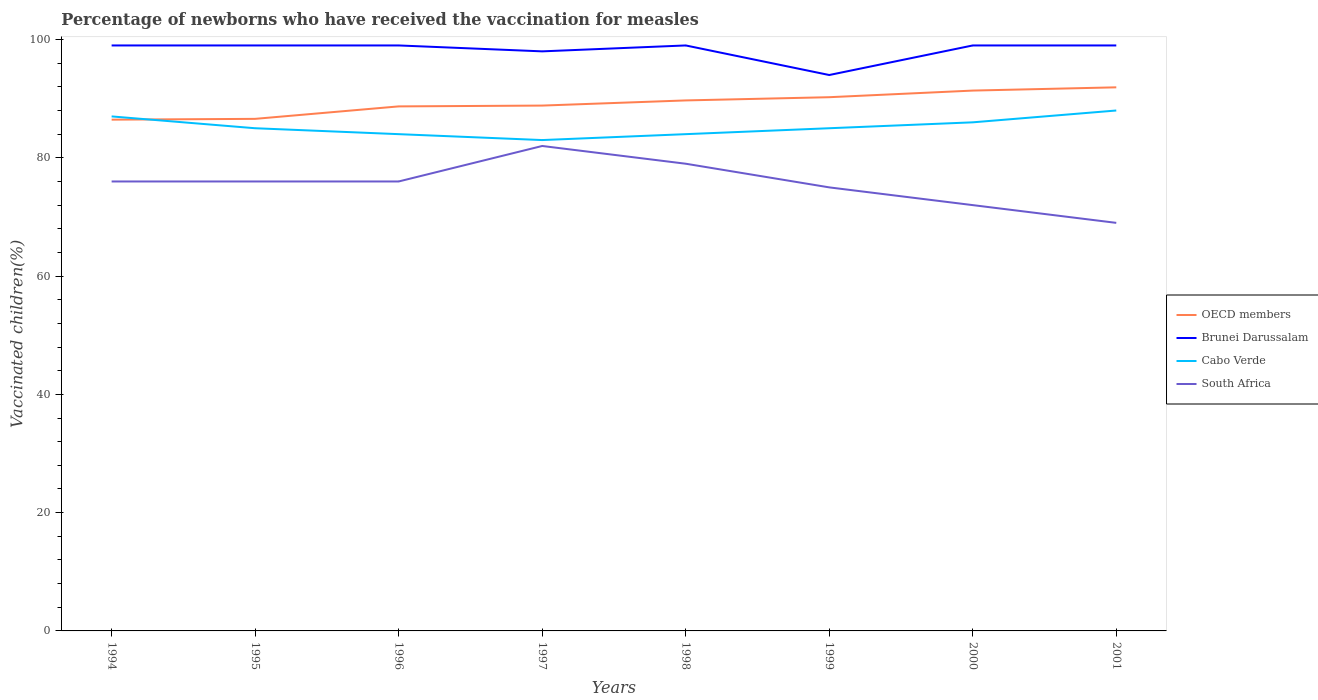Is the number of lines equal to the number of legend labels?
Your response must be concise. Yes. In which year was the percentage of vaccinated children in Brunei Darussalam maximum?
Your answer should be compact. 1999. What is the difference between the highest and the second highest percentage of vaccinated children in Brunei Darussalam?
Offer a very short reply. 5. Is the percentage of vaccinated children in OECD members strictly greater than the percentage of vaccinated children in Brunei Darussalam over the years?
Give a very brief answer. Yes. How many years are there in the graph?
Ensure brevity in your answer.  8. What is the difference between two consecutive major ticks on the Y-axis?
Offer a terse response. 20. Are the values on the major ticks of Y-axis written in scientific E-notation?
Keep it short and to the point. No. Does the graph contain any zero values?
Ensure brevity in your answer.  No. Does the graph contain grids?
Provide a succinct answer. No. What is the title of the graph?
Your answer should be compact. Percentage of newborns who have received the vaccination for measles. Does "Northern Mariana Islands" appear as one of the legend labels in the graph?
Provide a succinct answer. No. What is the label or title of the X-axis?
Offer a very short reply. Years. What is the label or title of the Y-axis?
Ensure brevity in your answer.  Vaccinated children(%). What is the Vaccinated children(%) of OECD members in 1994?
Provide a succinct answer. 86.45. What is the Vaccinated children(%) in Cabo Verde in 1994?
Your answer should be very brief. 87. What is the Vaccinated children(%) of OECD members in 1995?
Offer a very short reply. 86.59. What is the Vaccinated children(%) of South Africa in 1995?
Offer a very short reply. 76. What is the Vaccinated children(%) of OECD members in 1996?
Provide a short and direct response. 88.69. What is the Vaccinated children(%) of Cabo Verde in 1996?
Ensure brevity in your answer.  84. What is the Vaccinated children(%) in OECD members in 1997?
Make the answer very short. 88.83. What is the Vaccinated children(%) in Brunei Darussalam in 1997?
Ensure brevity in your answer.  98. What is the Vaccinated children(%) in Cabo Verde in 1997?
Give a very brief answer. 83. What is the Vaccinated children(%) of OECD members in 1998?
Your answer should be compact. 89.7. What is the Vaccinated children(%) of Brunei Darussalam in 1998?
Your answer should be very brief. 99. What is the Vaccinated children(%) in Cabo Verde in 1998?
Offer a very short reply. 84. What is the Vaccinated children(%) in South Africa in 1998?
Your response must be concise. 79. What is the Vaccinated children(%) of OECD members in 1999?
Your answer should be very brief. 90.25. What is the Vaccinated children(%) of Brunei Darussalam in 1999?
Provide a short and direct response. 94. What is the Vaccinated children(%) of Cabo Verde in 1999?
Offer a very short reply. 85. What is the Vaccinated children(%) in OECD members in 2000?
Keep it short and to the point. 91.37. What is the Vaccinated children(%) of Brunei Darussalam in 2000?
Give a very brief answer. 99. What is the Vaccinated children(%) of OECD members in 2001?
Provide a short and direct response. 91.92. What is the Vaccinated children(%) in Brunei Darussalam in 2001?
Offer a very short reply. 99. What is the Vaccinated children(%) in Cabo Verde in 2001?
Provide a short and direct response. 88. What is the Vaccinated children(%) in South Africa in 2001?
Your answer should be very brief. 69. Across all years, what is the maximum Vaccinated children(%) in OECD members?
Your response must be concise. 91.92. Across all years, what is the maximum Vaccinated children(%) of Cabo Verde?
Your answer should be very brief. 88. Across all years, what is the minimum Vaccinated children(%) of OECD members?
Ensure brevity in your answer.  86.45. Across all years, what is the minimum Vaccinated children(%) of Brunei Darussalam?
Keep it short and to the point. 94. Across all years, what is the minimum Vaccinated children(%) in South Africa?
Provide a short and direct response. 69. What is the total Vaccinated children(%) in OECD members in the graph?
Ensure brevity in your answer.  713.81. What is the total Vaccinated children(%) of Brunei Darussalam in the graph?
Your answer should be compact. 786. What is the total Vaccinated children(%) in Cabo Verde in the graph?
Ensure brevity in your answer.  682. What is the total Vaccinated children(%) in South Africa in the graph?
Give a very brief answer. 605. What is the difference between the Vaccinated children(%) of OECD members in 1994 and that in 1995?
Ensure brevity in your answer.  -0.14. What is the difference between the Vaccinated children(%) in Brunei Darussalam in 1994 and that in 1995?
Provide a short and direct response. 0. What is the difference between the Vaccinated children(%) of Cabo Verde in 1994 and that in 1995?
Keep it short and to the point. 2. What is the difference between the Vaccinated children(%) of South Africa in 1994 and that in 1995?
Your response must be concise. 0. What is the difference between the Vaccinated children(%) in OECD members in 1994 and that in 1996?
Keep it short and to the point. -2.24. What is the difference between the Vaccinated children(%) of Cabo Verde in 1994 and that in 1996?
Offer a very short reply. 3. What is the difference between the Vaccinated children(%) of OECD members in 1994 and that in 1997?
Offer a very short reply. -2.38. What is the difference between the Vaccinated children(%) of Brunei Darussalam in 1994 and that in 1997?
Provide a short and direct response. 1. What is the difference between the Vaccinated children(%) of South Africa in 1994 and that in 1997?
Provide a succinct answer. -6. What is the difference between the Vaccinated children(%) in OECD members in 1994 and that in 1998?
Provide a succinct answer. -3.25. What is the difference between the Vaccinated children(%) of Cabo Verde in 1994 and that in 1998?
Provide a short and direct response. 3. What is the difference between the Vaccinated children(%) of South Africa in 1994 and that in 1998?
Ensure brevity in your answer.  -3. What is the difference between the Vaccinated children(%) of OECD members in 1994 and that in 1999?
Ensure brevity in your answer.  -3.8. What is the difference between the Vaccinated children(%) in Cabo Verde in 1994 and that in 1999?
Give a very brief answer. 2. What is the difference between the Vaccinated children(%) in South Africa in 1994 and that in 1999?
Your response must be concise. 1. What is the difference between the Vaccinated children(%) in OECD members in 1994 and that in 2000?
Your answer should be compact. -4.92. What is the difference between the Vaccinated children(%) of Cabo Verde in 1994 and that in 2000?
Ensure brevity in your answer.  1. What is the difference between the Vaccinated children(%) of South Africa in 1994 and that in 2000?
Your response must be concise. 4. What is the difference between the Vaccinated children(%) of OECD members in 1994 and that in 2001?
Your response must be concise. -5.47. What is the difference between the Vaccinated children(%) of OECD members in 1995 and that in 1996?
Provide a short and direct response. -2.11. What is the difference between the Vaccinated children(%) of Cabo Verde in 1995 and that in 1996?
Offer a very short reply. 1. What is the difference between the Vaccinated children(%) of OECD members in 1995 and that in 1997?
Give a very brief answer. -2.25. What is the difference between the Vaccinated children(%) of South Africa in 1995 and that in 1997?
Your response must be concise. -6. What is the difference between the Vaccinated children(%) of OECD members in 1995 and that in 1998?
Provide a short and direct response. -3.12. What is the difference between the Vaccinated children(%) in Brunei Darussalam in 1995 and that in 1998?
Offer a very short reply. 0. What is the difference between the Vaccinated children(%) in South Africa in 1995 and that in 1998?
Ensure brevity in your answer.  -3. What is the difference between the Vaccinated children(%) in OECD members in 1995 and that in 1999?
Keep it short and to the point. -3.66. What is the difference between the Vaccinated children(%) in Brunei Darussalam in 1995 and that in 1999?
Make the answer very short. 5. What is the difference between the Vaccinated children(%) in Cabo Verde in 1995 and that in 1999?
Offer a very short reply. 0. What is the difference between the Vaccinated children(%) in OECD members in 1995 and that in 2000?
Provide a succinct answer. -4.78. What is the difference between the Vaccinated children(%) of Brunei Darussalam in 1995 and that in 2000?
Offer a very short reply. 0. What is the difference between the Vaccinated children(%) of South Africa in 1995 and that in 2000?
Keep it short and to the point. 4. What is the difference between the Vaccinated children(%) in OECD members in 1995 and that in 2001?
Offer a terse response. -5.33. What is the difference between the Vaccinated children(%) in Brunei Darussalam in 1995 and that in 2001?
Offer a very short reply. 0. What is the difference between the Vaccinated children(%) in Cabo Verde in 1995 and that in 2001?
Keep it short and to the point. -3. What is the difference between the Vaccinated children(%) in OECD members in 1996 and that in 1997?
Provide a succinct answer. -0.14. What is the difference between the Vaccinated children(%) of Brunei Darussalam in 1996 and that in 1997?
Your answer should be compact. 1. What is the difference between the Vaccinated children(%) of South Africa in 1996 and that in 1997?
Ensure brevity in your answer.  -6. What is the difference between the Vaccinated children(%) in OECD members in 1996 and that in 1998?
Provide a short and direct response. -1.01. What is the difference between the Vaccinated children(%) in Brunei Darussalam in 1996 and that in 1998?
Your response must be concise. 0. What is the difference between the Vaccinated children(%) in OECD members in 1996 and that in 1999?
Ensure brevity in your answer.  -1.55. What is the difference between the Vaccinated children(%) in Brunei Darussalam in 1996 and that in 1999?
Provide a short and direct response. 5. What is the difference between the Vaccinated children(%) in Cabo Verde in 1996 and that in 1999?
Provide a succinct answer. -1. What is the difference between the Vaccinated children(%) in South Africa in 1996 and that in 1999?
Your answer should be compact. 1. What is the difference between the Vaccinated children(%) of OECD members in 1996 and that in 2000?
Keep it short and to the point. -2.67. What is the difference between the Vaccinated children(%) of Cabo Verde in 1996 and that in 2000?
Ensure brevity in your answer.  -2. What is the difference between the Vaccinated children(%) in South Africa in 1996 and that in 2000?
Make the answer very short. 4. What is the difference between the Vaccinated children(%) of OECD members in 1996 and that in 2001?
Provide a succinct answer. -3.22. What is the difference between the Vaccinated children(%) of Cabo Verde in 1996 and that in 2001?
Your answer should be very brief. -4. What is the difference between the Vaccinated children(%) in South Africa in 1996 and that in 2001?
Offer a very short reply. 7. What is the difference between the Vaccinated children(%) in OECD members in 1997 and that in 1998?
Make the answer very short. -0.87. What is the difference between the Vaccinated children(%) of Brunei Darussalam in 1997 and that in 1998?
Your response must be concise. -1. What is the difference between the Vaccinated children(%) of South Africa in 1997 and that in 1998?
Give a very brief answer. 3. What is the difference between the Vaccinated children(%) in OECD members in 1997 and that in 1999?
Keep it short and to the point. -1.41. What is the difference between the Vaccinated children(%) of Cabo Verde in 1997 and that in 1999?
Offer a very short reply. -2. What is the difference between the Vaccinated children(%) of OECD members in 1997 and that in 2000?
Your answer should be very brief. -2.54. What is the difference between the Vaccinated children(%) in South Africa in 1997 and that in 2000?
Give a very brief answer. 10. What is the difference between the Vaccinated children(%) of OECD members in 1997 and that in 2001?
Keep it short and to the point. -3.08. What is the difference between the Vaccinated children(%) of South Africa in 1997 and that in 2001?
Provide a succinct answer. 13. What is the difference between the Vaccinated children(%) of OECD members in 1998 and that in 1999?
Your answer should be very brief. -0.54. What is the difference between the Vaccinated children(%) of Cabo Verde in 1998 and that in 1999?
Keep it short and to the point. -1. What is the difference between the Vaccinated children(%) of OECD members in 1998 and that in 2000?
Provide a short and direct response. -1.67. What is the difference between the Vaccinated children(%) of Brunei Darussalam in 1998 and that in 2000?
Your response must be concise. 0. What is the difference between the Vaccinated children(%) of Cabo Verde in 1998 and that in 2000?
Ensure brevity in your answer.  -2. What is the difference between the Vaccinated children(%) of South Africa in 1998 and that in 2000?
Keep it short and to the point. 7. What is the difference between the Vaccinated children(%) in OECD members in 1998 and that in 2001?
Provide a short and direct response. -2.21. What is the difference between the Vaccinated children(%) of OECD members in 1999 and that in 2000?
Ensure brevity in your answer.  -1.12. What is the difference between the Vaccinated children(%) of South Africa in 1999 and that in 2000?
Your answer should be very brief. 3. What is the difference between the Vaccinated children(%) of OECD members in 1999 and that in 2001?
Offer a very short reply. -1.67. What is the difference between the Vaccinated children(%) in Cabo Verde in 1999 and that in 2001?
Offer a very short reply. -3. What is the difference between the Vaccinated children(%) of South Africa in 1999 and that in 2001?
Offer a very short reply. 6. What is the difference between the Vaccinated children(%) in OECD members in 2000 and that in 2001?
Keep it short and to the point. -0.55. What is the difference between the Vaccinated children(%) in Brunei Darussalam in 2000 and that in 2001?
Your answer should be compact. 0. What is the difference between the Vaccinated children(%) of Cabo Verde in 2000 and that in 2001?
Your response must be concise. -2. What is the difference between the Vaccinated children(%) in OECD members in 1994 and the Vaccinated children(%) in Brunei Darussalam in 1995?
Your answer should be very brief. -12.55. What is the difference between the Vaccinated children(%) of OECD members in 1994 and the Vaccinated children(%) of Cabo Verde in 1995?
Your response must be concise. 1.45. What is the difference between the Vaccinated children(%) of OECD members in 1994 and the Vaccinated children(%) of South Africa in 1995?
Provide a short and direct response. 10.45. What is the difference between the Vaccinated children(%) in Brunei Darussalam in 1994 and the Vaccinated children(%) in South Africa in 1995?
Provide a short and direct response. 23. What is the difference between the Vaccinated children(%) of Cabo Verde in 1994 and the Vaccinated children(%) of South Africa in 1995?
Your response must be concise. 11. What is the difference between the Vaccinated children(%) of OECD members in 1994 and the Vaccinated children(%) of Brunei Darussalam in 1996?
Provide a short and direct response. -12.55. What is the difference between the Vaccinated children(%) in OECD members in 1994 and the Vaccinated children(%) in Cabo Verde in 1996?
Make the answer very short. 2.45. What is the difference between the Vaccinated children(%) in OECD members in 1994 and the Vaccinated children(%) in South Africa in 1996?
Make the answer very short. 10.45. What is the difference between the Vaccinated children(%) of Brunei Darussalam in 1994 and the Vaccinated children(%) of Cabo Verde in 1996?
Ensure brevity in your answer.  15. What is the difference between the Vaccinated children(%) of Brunei Darussalam in 1994 and the Vaccinated children(%) of South Africa in 1996?
Offer a terse response. 23. What is the difference between the Vaccinated children(%) in Cabo Verde in 1994 and the Vaccinated children(%) in South Africa in 1996?
Give a very brief answer. 11. What is the difference between the Vaccinated children(%) of OECD members in 1994 and the Vaccinated children(%) of Brunei Darussalam in 1997?
Provide a short and direct response. -11.55. What is the difference between the Vaccinated children(%) of OECD members in 1994 and the Vaccinated children(%) of Cabo Verde in 1997?
Your answer should be compact. 3.45. What is the difference between the Vaccinated children(%) of OECD members in 1994 and the Vaccinated children(%) of South Africa in 1997?
Ensure brevity in your answer.  4.45. What is the difference between the Vaccinated children(%) in Brunei Darussalam in 1994 and the Vaccinated children(%) in Cabo Verde in 1997?
Ensure brevity in your answer.  16. What is the difference between the Vaccinated children(%) of OECD members in 1994 and the Vaccinated children(%) of Brunei Darussalam in 1998?
Your answer should be very brief. -12.55. What is the difference between the Vaccinated children(%) of OECD members in 1994 and the Vaccinated children(%) of Cabo Verde in 1998?
Give a very brief answer. 2.45. What is the difference between the Vaccinated children(%) in OECD members in 1994 and the Vaccinated children(%) in South Africa in 1998?
Give a very brief answer. 7.45. What is the difference between the Vaccinated children(%) of Brunei Darussalam in 1994 and the Vaccinated children(%) of Cabo Verde in 1998?
Provide a succinct answer. 15. What is the difference between the Vaccinated children(%) in Brunei Darussalam in 1994 and the Vaccinated children(%) in South Africa in 1998?
Make the answer very short. 20. What is the difference between the Vaccinated children(%) in OECD members in 1994 and the Vaccinated children(%) in Brunei Darussalam in 1999?
Offer a terse response. -7.55. What is the difference between the Vaccinated children(%) of OECD members in 1994 and the Vaccinated children(%) of Cabo Verde in 1999?
Offer a terse response. 1.45. What is the difference between the Vaccinated children(%) in OECD members in 1994 and the Vaccinated children(%) in South Africa in 1999?
Make the answer very short. 11.45. What is the difference between the Vaccinated children(%) of Cabo Verde in 1994 and the Vaccinated children(%) of South Africa in 1999?
Make the answer very short. 12. What is the difference between the Vaccinated children(%) of OECD members in 1994 and the Vaccinated children(%) of Brunei Darussalam in 2000?
Provide a succinct answer. -12.55. What is the difference between the Vaccinated children(%) of OECD members in 1994 and the Vaccinated children(%) of Cabo Verde in 2000?
Your response must be concise. 0.45. What is the difference between the Vaccinated children(%) in OECD members in 1994 and the Vaccinated children(%) in South Africa in 2000?
Provide a succinct answer. 14.45. What is the difference between the Vaccinated children(%) in Brunei Darussalam in 1994 and the Vaccinated children(%) in South Africa in 2000?
Offer a terse response. 27. What is the difference between the Vaccinated children(%) in OECD members in 1994 and the Vaccinated children(%) in Brunei Darussalam in 2001?
Your response must be concise. -12.55. What is the difference between the Vaccinated children(%) in OECD members in 1994 and the Vaccinated children(%) in Cabo Verde in 2001?
Your answer should be compact. -1.55. What is the difference between the Vaccinated children(%) in OECD members in 1994 and the Vaccinated children(%) in South Africa in 2001?
Provide a short and direct response. 17.45. What is the difference between the Vaccinated children(%) of Brunei Darussalam in 1994 and the Vaccinated children(%) of Cabo Verde in 2001?
Your response must be concise. 11. What is the difference between the Vaccinated children(%) in Brunei Darussalam in 1994 and the Vaccinated children(%) in South Africa in 2001?
Your answer should be compact. 30. What is the difference between the Vaccinated children(%) of Cabo Verde in 1994 and the Vaccinated children(%) of South Africa in 2001?
Offer a terse response. 18. What is the difference between the Vaccinated children(%) of OECD members in 1995 and the Vaccinated children(%) of Brunei Darussalam in 1996?
Give a very brief answer. -12.41. What is the difference between the Vaccinated children(%) of OECD members in 1995 and the Vaccinated children(%) of Cabo Verde in 1996?
Your response must be concise. 2.59. What is the difference between the Vaccinated children(%) of OECD members in 1995 and the Vaccinated children(%) of South Africa in 1996?
Offer a very short reply. 10.59. What is the difference between the Vaccinated children(%) of Brunei Darussalam in 1995 and the Vaccinated children(%) of Cabo Verde in 1996?
Keep it short and to the point. 15. What is the difference between the Vaccinated children(%) of Brunei Darussalam in 1995 and the Vaccinated children(%) of South Africa in 1996?
Your answer should be compact. 23. What is the difference between the Vaccinated children(%) of Cabo Verde in 1995 and the Vaccinated children(%) of South Africa in 1996?
Offer a terse response. 9. What is the difference between the Vaccinated children(%) in OECD members in 1995 and the Vaccinated children(%) in Brunei Darussalam in 1997?
Make the answer very short. -11.41. What is the difference between the Vaccinated children(%) in OECD members in 1995 and the Vaccinated children(%) in Cabo Verde in 1997?
Ensure brevity in your answer.  3.59. What is the difference between the Vaccinated children(%) of OECD members in 1995 and the Vaccinated children(%) of South Africa in 1997?
Provide a succinct answer. 4.59. What is the difference between the Vaccinated children(%) in OECD members in 1995 and the Vaccinated children(%) in Brunei Darussalam in 1998?
Ensure brevity in your answer.  -12.41. What is the difference between the Vaccinated children(%) of OECD members in 1995 and the Vaccinated children(%) of Cabo Verde in 1998?
Your answer should be very brief. 2.59. What is the difference between the Vaccinated children(%) of OECD members in 1995 and the Vaccinated children(%) of South Africa in 1998?
Keep it short and to the point. 7.59. What is the difference between the Vaccinated children(%) in Brunei Darussalam in 1995 and the Vaccinated children(%) in Cabo Verde in 1998?
Provide a succinct answer. 15. What is the difference between the Vaccinated children(%) in Brunei Darussalam in 1995 and the Vaccinated children(%) in South Africa in 1998?
Offer a very short reply. 20. What is the difference between the Vaccinated children(%) in OECD members in 1995 and the Vaccinated children(%) in Brunei Darussalam in 1999?
Your answer should be compact. -7.41. What is the difference between the Vaccinated children(%) of OECD members in 1995 and the Vaccinated children(%) of Cabo Verde in 1999?
Offer a terse response. 1.59. What is the difference between the Vaccinated children(%) in OECD members in 1995 and the Vaccinated children(%) in South Africa in 1999?
Provide a short and direct response. 11.59. What is the difference between the Vaccinated children(%) of Brunei Darussalam in 1995 and the Vaccinated children(%) of South Africa in 1999?
Offer a very short reply. 24. What is the difference between the Vaccinated children(%) of OECD members in 1995 and the Vaccinated children(%) of Brunei Darussalam in 2000?
Your response must be concise. -12.41. What is the difference between the Vaccinated children(%) of OECD members in 1995 and the Vaccinated children(%) of Cabo Verde in 2000?
Ensure brevity in your answer.  0.59. What is the difference between the Vaccinated children(%) in OECD members in 1995 and the Vaccinated children(%) in South Africa in 2000?
Give a very brief answer. 14.59. What is the difference between the Vaccinated children(%) in Brunei Darussalam in 1995 and the Vaccinated children(%) in Cabo Verde in 2000?
Provide a succinct answer. 13. What is the difference between the Vaccinated children(%) of Brunei Darussalam in 1995 and the Vaccinated children(%) of South Africa in 2000?
Your response must be concise. 27. What is the difference between the Vaccinated children(%) of OECD members in 1995 and the Vaccinated children(%) of Brunei Darussalam in 2001?
Offer a terse response. -12.41. What is the difference between the Vaccinated children(%) of OECD members in 1995 and the Vaccinated children(%) of Cabo Verde in 2001?
Provide a succinct answer. -1.41. What is the difference between the Vaccinated children(%) of OECD members in 1995 and the Vaccinated children(%) of South Africa in 2001?
Make the answer very short. 17.59. What is the difference between the Vaccinated children(%) of Brunei Darussalam in 1995 and the Vaccinated children(%) of Cabo Verde in 2001?
Provide a short and direct response. 11. What is the difference between the Vaccinated children(%) of Cabo Verde in 1995 and the Vaccinated children(%) of South Africa in 2001?
Your response must be concise. 16. What is the difference between the Vaccinated children(%) in OECD members in 1996 and the Vaccinated children(%) in Brunei Darussalam in 1997?
Provide a succinct answer. -9.31. What is the difference between the Vaccinated children(%) in OECD members in 1996 and the Vaccinated children(%) in Cabo Verde in 1997?
Your answer should be compact. 5.69. What is the difference between the Vaccinated children(%) of OECD members in 1996 and the Vaccinated children(%) of South Africa in 1997?
Offer a terse response. 6.69. What is the difference between the Vaccinated children(%) of Brunei Darussalam in 1996 and the Vaccinated children(%) of Cabo Verde in 1997?
Give a very brief answer. 16. What is the difference between the Vaccinated children(%) in OECD members in 1996 and the Vaccinated children(%) in Brunei Darussalam in 1998?
Offer a terse response. -10.31. What is the difference between the Vaccinated children(%) in OECD members in 1996 and the Vaccinated children(%) in Cabo Verde in 1998?
Ensure brevity in your answer.  4.69. What is the difference between the Vaccinated children(%) of OECD members in 1996 and the Vaccinated children(%) of South Africa in 1998?
Ensure brevity in your answer.  9.69. What is the difference between the Vaccinated children(%) of Brunei Darussalam in 1996 and the Vaccinated children(%) of South Africa in 1998?
Offer a very short reply. 20. What is the difference between the Vaccinated children(%) in Cabo Verde in 1996 and the Vaccinated children(%) in South Africa in 1998?
Offer a terse response. 5. What is the difference between the Vaccinated children(%) of OECD members in 1996 and the Vaccinated children(%) of Brunei Darussalam in 1999?
Keep it short and to the point. -5.31. What is the difference between the Vaccinated children(%) of OECD members in 1996 and the Vaccinated children(%) of Cabo Verde in 1999?
Ensure brevity in your answer.  3.69. What is the difference between the Vaccinated children(%) of OECD members in 1996 and the Vaccinated children(%) of South Africa in 1999?
Provide a succinct answer. 13.69. What is the difference between the Vaccinated children(%) in Cabo Verde in 1996 and the Vaccinated children(%) in South Africa in 1999?
Your response must be concise. 9. What is the difference between the Vaccinated children(%) in OECD members in 1996 and the Vaccinated children(%) in Brunei Darussalam in 2000?
Offer a terse response. -10.31. What is the difference between the Vaccinated children(%) in OECD members in 1996 and the Vaccinated children(%) in Cabo Verde in 2000?
Make the answer very short. 2.69. What is the difference between the Vaccinated children(%) of OECD members in 1996 and the Vaccinated children(%) of South Africa in 2000?
Provide a succinct answer. 16.69. What is the difference between the Vaccinated children(%) in Brunei Darussalam in 1996 and the Vaccinated children(%) in Cabo Verde in 2000?
Ensure brevity in your answer.  13. What is the difference between the Vaccinated children(%) in OECD members in 1996 and the Vaccinated children(%) in Brunei Darussalam in 2001?
Your answer should be compact. -10.31. What is the difference between the Vaccinated children(%) of OECD members in 1996 and the Vaccinated children(%) of Cabo Verde in 2001?
Ensure brevity in your answer.  0.69. What is the difference between the Vaccinated children(%) in OECD members in 1996 and the Vaccinated children(%) in South Africa in 2001?
Your answer should be very brief. 19.69. What is the difference between the Vaccinated children(%) in Brunei Darussalam in 1996 and the Vaccinated children(%) in Cabo Verde in 2001?
Ensure brevity in your answer.  11. What is the difference between the Vaccinated children(%) in OECD members in 1997 and the Vaccinated children(%) in Brunei Darussalam in 1998?
Give a very brief answer. -10.17. What is the difference between the Vaccinated children(%) in OECD members in 1997 and the Vaccinated children(%) in Cabo Verde in 1998?
Your answer should be compact. 4.83. What is the difference between the Vaccinated children(%) of OECD members in 1997 and the Vaccinated children(%) of South Africa in 1998?
Provide a short and direct response. 9.83. What is the difference between the Vaccinated children(%) in Cabo Verde in 1997 and the Vaccinated children(%) in South Africa in 1998?
Your answer should be very brief. 4. What is the difference between the Vaccinated children(%) in OECD members in 1997 and the Vaccinated children(%) in Brunei Darussalam in 1999?
Provide a succinct answer. -5.17. What is the difference between the Vaccinated children(%) of OECD members in 1997 and the Vaccinated children(%) of Cabo Verde in 1999?
Your response must be concise. 3.83. What is the difference between the Vaccinated children(%) of OECD members in 1997 and the Vaccinated children(%) of South Africa in 1999?
Your answer should be compact. 13.83. What is the difference between the Vaccinated children(%) of Brunei Darussalam in 1997 and the Vaccinated children(%) of South Africa in 1999?
Your response must be concise. 23. What is the difference between the Vaccinated children(%) in OECD members in 1997 and the Vaccinated children(%) in Brunei Darussalam in 2000?
Your response must be concise. -10.17. What is the difference between the Vaccinated children(%) of OECD members in 1997 and the Vaccinated children(%) of Cabo Verde in 2000?
Offer a very short reply. 2.83. What is the difference between the Vaccinated children(%) in OECD members in 1997 and the Vaccinated children(%) in South Africa in 2000?
Give a very brief answer. 16.83. What is the difference between the Vaccinated children(%) of Brunei Darussalam in 1997 and the Vaccinated children(%) of South Africa in 2000?
Offer a very short reply. 26. What is the difference between the Vaccinated children(%) in OECD members in 1997 and the Vaccinated children(%) in Brunei Darussalam in 2001?
Offer a terse response. -10.17. What is the difference between the Vaccinated children(%) of OECD members in 1997 and the Vaccinated children(%) of Cabo Verde in 2001?
Offer a terse response. 0.83. What is the difference between the Vaccinated children(%) of OECD members in 1997 and the Vaccinated children(%) of South Africa in 2001?
Your answer should be compact. 19.83. What is the difference between the Vaccinated children(%) of Brunei Darussalam in 1997 and the Vaccinated children(%) of South Africa in 2001?
Provide a short and direct response. 29. What is the difference between the Vaccinated children(%) in OECD members in 1998 and the Vaccinated children(%) in Brunei Darussalam in 1999?
Your answer should be compact. -4.3. What is the difference between the Vaccinated children(%) of OECD members in 1998 and the Vaccinated children(%) of Cabo Verde in 1999?
Offer a terse response. 4.7. What is the difference between the Vaccinated children(%) in OECD members in 1998 and the Vaccinated children(%) in South Africa in 1999?
Your answer should be very brief. 14.7. What is the difference between the Vaccinated children(%) of Brunei Darussalam in 1998 and the Vaccinated children(%) of Cabo Verde in 1999?
Ensure brevity in your answer.  14. What is the difference between the Vaccinated children(%) in Brunei Darussalam in 1998 and the Vaccinated children(%) in South Africa in 1999?
Provide a short and direct response. 24. What is the difference between the Vaccinated children(%) in OECD members in 1998 and the Vaccinated children(%) in Brunei Darussalam in 2000?
Your answer should be compact. -9.3. What is the difference between the Vaccinated children(%) of OECD members in 1998 and the Vaccinated children(%) of Cabo Verde in 2000?
Offer a terse response. 3.7. What is the difference between the Vaccinated children(%) in OECD members in 1998 and the Vaccinated children(%) in South Africa in 2000?
Make the answer very short. 17.7. What is the difference between the Vaccinated children(%) in Brunei Darussalam in 1998 and the Vaccinated children(%) in Cabo Verde in 2000?
Your answer should be compact. 13. What is the difference between the Vaccinated children(%) in Cabo Verde in 1998 and the Vaccinated children(%) in South Africa in 2000?
Make the answer very short. 12. What is the difference between the Vaccinated children(%) in OECD members in 1998 and the Vaccinated children(%) in Brunei Darussalam in 2001?
Your answer should be compact. -9.3. What is the difference between the Vaccinated children(%) in OECD members in 1998 and the Vaccinated children(%) in Cabo Verde in 2001?
Make the answer very short. 1.7. What is the difference between the Vaccinated children(%) in OECD members in 1998 and the Vaccinated children(%) in South Africa in 2001?
Your answer should be compact. 20.7. What is the difference between the Vaccinated children(%) in Brunei Darussalam in 1998 and the Vaccinated children(%) in South Africa in 2001?
Ensure brevity in your answer.  30. What is the difference between the Vaccinated children(%) in Cabo Verde in 1998 and the Vaccinated children(%) in South Africa in 2001?
Provide a short and direct response. 15. What is the difference between the Vaccinated children(%) in OECD members in 1999 and the Vaccinated children(%) in Brunei Darussalam in 2000?
Provide a succinct answer. -8.75. What is the difference between the Vaccinated children(%) of OECD members in 1999 and the Vaccinated children(%) of Cabo Verde in 2000?
Give a very brief answer. 4.25. What is the difference between the Vaccinated children(%) in OECD members in 1999 and the Vaccinated children(%) in South Africa in 2000?
Provide a succinct answer. 18.25. What is the difference between the Vaccinated children(%) of Brunei Darussalam in 1999 and the Vaccinated children(%) of Cabo Verde in 2000?
Provide a succinct answer. 8. What is the difference between the Vaccinated children(%) of Brunei Darussalam in 1999 and the Vaccinated children(%) of South Africa in 2000?
Offer a very short reply. 22. What is the difference between the Vaccinated children(%) in Cabo Verde in 1999 and the Vaccinated children(%) in South Africa in 2000?
Your response must be concise. 13. What is the difference between the Vaccinated children(%) of OECD members in 1999 and the Vaccinated children(%) of Brunei Darussalam in 2001?
Your response must be concise. -8.75. What is the difference between the Vaccinated children(%) in OECD members in 1999 and the Vaccinated children(%) in Cabo Verde in 2001?
Keep it short and to the point. 2.25. What is the difference between the Vaccinated children(%) of OECD members in 1999 and the Vaccinated children(%) of South Africa in 2001?
Keep it short and to the point. 21.25. What is the difference between the Vaccinated children(%) in OECD members in 2000 and the Vaccinated children(%) in Brunei Darussalam in 2001?
Your answer should be very brief. -7.63. What is the difference between the Vaccinated children(%) of OECD members in 2000 and the Vaccinated children(%) of Cabo Verde in 2001?
Your response must be concise. 3.37. What is the difference between the Vaccinated children(%) in OECD members in 2000 and the Vaccinated children(%) in South Africa in 2001?
Your answer should be very brief. 22.37. What is the difference between the Vaccinated children(%) of Brunei Darussalam in 2000 and the Vaccinated children(%) of South Africa in 2001?
Offer a terse response. 30. What is the average Vaccinated children(%) of OECD members per year?
Provide a short and direct response. 89.23. What is the average Vaccinated children(%) of Brunei Darussalam per year?
Give a very brief answer. 98.25. What is the average Vaccinated children(%) of Cabo Verde per year?
Make the answer very short. 85.25. What is the average Vaccinated children(%) of South Africa per year?
Provide a short and direct response. 75.62. In the year 1994, what is the difference between the Vaccinated children(%) of OECD members and Vaccinated children(%) of Brunei Darussalam?
Your answer should be very brief. -12.55. In the year 1994, what is the difference between the Vaccinated children(%) in OECD members and Vaccinated children(%) in Cabo Verde?
Give a very brief answer. -0.55. In the year 1994, what is the difference between the Vaccinated children(%) of OECD members and Vaccinated children(%) of South Africa?
Offer a very short reply. 10.45. In the year 1994, what is the difference between the Vaccinated children(%) in Cabo Verde and Vaccinated children(%) in South Africa?
Give a very brief answer. 11. In the year 1995, what is the difference between the Vaccinated children(%) of OECD members and Vaccinated children(%) of Brunei Darussalam?
Make the answer very short. -12.41. In the year 1995, what is the difference between the Vaccinated children(%) in OECD members and Vaccinated children(%) in Cabo Verde?
Provide a succinct answer. 1.59. In the year 1995, what is the difference between the Vaccinated children(%) of OECD members and Vaccinated children(%) of South Africa?
Ensure brevity in your answer.  10.59. In the year 1996, what is the difference between the Vaccinated children(%) in OECD members and Vaccinated children(%) in Brunei Darussalam?
Your response must be concise. -10.31. In the year 1996, what is the difference between the Vaccinated children(%) of OECD members and Vaccinated children(%) of Cabo Verde?
Give a very brief answer. 4.69. In the year 1996, what is the difference between the Vaccinated children(%) in OECD members and Vaccinated children(%) in South Africa?
Your response must be concise. 12.69. In the year 1997, what is the difference between the Vaccinated children(%) in OECD members and Vaccinated children(%) in Brunei Darussalam?
Offer a very short reply. -9.17. In the year 1997, what is the difference between the Vaccinated children(%) in OECD members and Vaccinated children(%) in Cabo Verde?
Your response must be concise. 5.83. In the year 1997, what is the difference between the Vaccinated children(%) in OECD members and Vaccinated children(%) in South Africa?
Offer a terse response. 6.83. In the year 1997, what is the difference between the Vaccinated children(%) in Brunei Darussalam and Vaccinated children(%) in Cabo Verde?
Offer a terse response. 15. In the year 1998, what is the difference between the Vaccinated children(%) of OECD members and Vaccinated children(%) of Brunei Darussalam?
Offer a terse response. -9.3. In the year 1998, what is the difference between the Vaccinated children(%) of OECD members and Vaccinated children(%) of Cabo Verde?
Your answer should be very brief. 5.7. In the year 1998, what is the difference between the Vaccinated children(%) of OECD members and Vaccinated children(%) of South Africa?
Ensure brevity in your answer.  10.7. In the year 1998, what is the difference between the Vaccinated children(%) in Cabo Verde and Vaccinated children(%) in South Africa?
Offer a very short reply. 5. In the year 1999, what is the difference between the Vaccinated children(%) in OECD members and Vaccinated children(%) in Brunei Darussalam?
Ensure brevity in your answer.  -3.75. In the year 1999, what is the difference between the Vaccinated children(%) in OECD members and Vaccinated children(%) in Cabo Verde?
Keep it short and to the point. 5.25. In the year 1999, what is the difference between the Vaccinated children(%) of OECD members and Vaccinated children(%) of South Africa?
Keep it short and to the point. 15.25. In the year 1999, what is the difference between the Vaccinated children(%) of Brunei Darussalam and Vaccinated children(%) of South Africa?
Make the answer very short. 19. In the year 1999, what is the difference between the Vaccinated children(%) of Cabo Verde and Vaccinated children(%) of South Africa?
Your answer should be very brief. 10. In the year 2000, what is the difference between the Vaccinated children(%) in OECD members and Vaccinated children(%) in Brunei Darussalam?
Offer a terse response. -7.63. In the year 2000, what is the difference between the Vaccinated children(%) of OECD members and Vaccinated children(%) of Cabo Verde?
Make the answer very short. 5.37. In the year 2000, what is the difference between the Vaccinated children(%) in OECD members and Vaccinated children(%) in South Africa?
Give a very brief answer. 19.37. In the year 2000, what is the difference between the Vaccinated children(%) in Brunei Darussalam and Vaccinated children(%) in Cabo Verde?
Offer a very short reply. 13. In the year 2001, what is the difference between the Vaccinated children(%) in OECD members and Vaccinated children(%) in Brunei Darussalam?
Your answer should be compact. -7.08. In the year 2001, what is the difference between the Vaccinated children(%) of OECD members and Vaccinated children(%) of Cabo Verde?
Provide a succinct answer. 3.92. In the year 2001, what is the difference between the Vaccinated children(%) in OECD members and Vaccinated children(%) in South Africa?
Your response must be concise. 22.92. In the year 2001, what is the difference between the Vaccinated children(%) of Brunei Darussalam and Vaccinated children(%) of South Africa?
Your answer should be very brief. 30. In the year 2001, what is the difference between the Vaccinated children(%) in Cabo Verde and Vaccinated children(%) in South Africa?
Give a very brief answer. 19. What is the ratio of the Vaccinated children(%) of OECD members in 1994 to that in 1995?
Your answer should be compact. 1. What is the ratio of the Vaccinated children(%) in Brunei Darussalam in 1994 to that in 1995?
Offer a terse response. 1. What is the ratio of the Vaccinated children(%) of Cabo Verde in 1994 to that in 1995?
Offer a terse response. 1.02. What is the ratio of the Vaccinated children(%) in South Africa in 1994 to that in 1995?
Provide a succinct answer. 1. What is the ratio of the Vaccinated children(%) in OECD members in 1994 to that in 1996?
Provide a succinct answer. 0.97. What is the ratio of the Vaccinated children(%) in Cabo Verde in 1994 to that in 1996?
Offer a very short reply. 1.04. What is the ratio of the Vaccinated children(%) of OECD members in 1994 to that in 1997?
Your answer should be compact. 0.97. What is the ratio of the Vaccinated children(%) in Brunei Darussalam in 1994 to that in 1997?
Offer a terse response. 1.01. What is the ratio of the Vaccinated children(%) of Cabo Verde in 1994 to that in 1997?
Give a very brief answer. 1.05. What is the ratio of the Vaccinated children(%) in South Africa in 1994 to that in 1997?
Give a very brief answer. 0.93. What is the ratio of the Vaccinated children(%) in OECD members in 1994 to that in 1998?
Provide a short and direct response. 0.96. What is the ratio of the Vaccinated children(%) of Cabo Verde in 1994 to that in 1998?
Your response must be concise. 1.04. What is the ratio of the Vaccinated children(%) of OECD members in 1994 to that in 1999?
Provide a succinct answer. 0.96. What is the ratio of the Vaccinated children(%) in Brunei Darussalam in 1994 to that in 1999?
Make the answer very short. 1.05. What is the ratio of the Vaccinated children(%) in Cabo Verde in 1994 to that in 1999?
Your answer should be compact. 1.02. What is the ratio of the Vaccinated children(%) in South Africa in 1994 to that in 1999?
Provide a succinct answer. 1.01. What is the ratio of the Vaccinated children(%) of OECD members in 1994 to that in 2000?
Keep it short and to the point. 0.95. What is the ratio of the Vaccinated children(%) of Brunei Darussalam in 1994 to that in 2000?
Give a very brief answer. 1. What is the ratio of the Vaccinated children(%) in Cabo Verde in 1994 to that in 2000?
Ensure brevity in your answer.  1.01. What is the ratio of the Vaccinated children(%) of South Africa in 1994 to that in 2000?
Your response must be concise. 1.06. What is the ratio of the Vaccinated children(%) of OECD members in 1994 to that in 2001?
Your answer should be very brief. 0.94. What is the ratio of the Vaccinated children(%) in Brunei Darussalam in 1994 to that in 2001?
Give a very brief answer. 1. What is the ratio of the Vaccinated children(%) of South Africa in 1994 to that in 2001?
Give a very brief answer. 1.1. What is the ratio of the Vaccinated children(%) in OECD members in 1995 to that in 1996?
Give a very brief answer. 0.98. What is the ratio of the Vaccinated children(%) in Brunei Darussalam in 1995 to that in 1996?
Offer a terse response. 1. What is the ratio of the Vaccinated children(%) in Cabo Verde in 1995 to that in 1996?
Keep it short and to the point. 1.01. What is the ratio of the Vaccinated children(%) of OECD members in 1995 to that in 1997?
Provide a short and direct response. 0.97. What is the ratio of the Vaccinated children(%) in Brunei Darussalam in 1995 to that in 1997?
Offer a very short reply. 1.01. What is the ratio of the Vaccinated children(%) of Cabo Verde in 1995 to that in 1997?
Ensure brevity in your answer.  1.02. What is the ratio of the Vaccinated children(%) in South Africa in 1995 to that in 1997?
Keep it short and to the point. 0.93. What is the ratio of the Vaccinated children(%) of OECD members in 1995 to that in 1998?
Your response must be concise. 0.97. What is the ratio of the Vaccinated children(%) of Brunei Darussalam in 1995 to that in 1998?
Your answer should be compact. 1. What is the ratio of the Vaccinated children(%) of Cabo Verde in 1995 to that in 1998?
Provide a short and direct response. 1.01. What is the ratio of the Vaccinated children(%) of South Africa in 1995 to that in 1998?
Offer a terse response. 0.96. What is the ratio of the Vaccinated children(%) of OECD members in 1995 to that in 1999?
Provide a succinct answer. 0.96. What is the ratio of the Vaccinated children(%) of Brunei Darussalam in 1995 to that in 1999?
Provide a succinct answer. 1.05. What is the ratio of the Vaccinated children(%) of Cabo Verde in 1995 to that in 1999?
Offer a terse response. 1. What is the ratio of the Vaccinated children(%) in South Africa in 1995 to that in 1999?
Your answer should be very brief. 1.01. What is the ratio of the Vaccinated children(%) of OECD members in 1995 to that in 2000?
Provide a short and direct response. 0.95. What is the ratio of the Vaccinated children(%) in Cabo Verde in 1995 to that in 2000?
Give a very brief answer. 0.99. What is the ratio of the Vaccinated children(%) in South Africa in 1995 to that in 2000?
Offer a very short reply. 1.06. What is the ratio of the Vaccinated children(%) of OECD members in 1995 to that in 2001?
Give a very brief answer. 0.94. What is the ratio of the Vaccinated children(%) in Cabo Verde in 1995 to that in 2001?
Give a very brief answer. 0.97. What is the ratio of the Vaccinated children(%) of South Africa in 1995 to that in 2001?
Offer a very short reply. 1.1. What is the ratio of the Vaccinated children(%) in Brunei Darussalam in 1996 to that in 1997?
Provide a succinct answer. 1.01. What is the ratio of the Vaccinated children(%) of South Africa in 1996 to that in 1997?
Give a very brief answer. 0.93. What is the ratio of the Vaccinated children(%) in OECD members in 1996 to that in 1998?
Offer a terse response. 0.99. What is the ratio of the Vaccinated children(%) in OECD members in 1996 to that in 1999?
Provide a short and direct response. 0.98. What is the ratio of the Vaccinated children(%) in Brunei Darussalam in 1996 to that in 1999?
Give a very brief answer. 1.05. What is the ratio of the Vaccinated children(%) in South Africa in 1996 to that in 1999?
Provide a short and direct response. 1.01. What is the ratio of the Vaccinated children(%) in OECD members in 1996 to that in 2000?
Provide a short and direct response. 0.97. What is the ratio of the Vaccinated children(%) in Brunei Darussalam in 1996 to that in 2000?
Make the answer very short. 1. What is the ratio of the Vaccinated children(%) of Cabo Verde in 1996 to that in 2000?
Give a very brief answer. 0.98. What is the ratio of the Vaccinated children(%) of South Africa in 1996 to that in 2000?
Offer a terse response. 1.06. What is the ratio of the Vaccinated children(%) in OECD members in 1996 to that in 2001?
Your answer should be compact. 0.96. What is the ratio of the Vaccinated children(%) of Brunei Darussalam in 1996 to that in 2001?
Your answer should be compact. 1. What is the ratio of the Vaccinated children(%) in Cabo Verde in 1996 to that in 2001?
Ensure brevity in your answer.  0.95. What is the ratio of the Vaccinated children(%) in South Africa in 1996 to that in 2001?
Your answer should be very brief. 1.1. What is the ratio of the Vaccinated children(%) of OECD members in 1997 to that in 1998?
Offer a very short reply. 0.99. What is the ratio of the Vaccinated children(%) in Cabo Verde in 1997 to that in 1998?
Ensure brevity in your answer.  0.99. What is the ratio of the Vaccinated children(%) in South Africa in 1997 to that in 1998?
Your answer should be very brief. 1.04. What is the ratio of the Vaccinated children(%) of OECD members in 1997 to that in 1999?
Make the answer very short. 0.98. What is the ratio of the Vaccinated children(%) of Brunei Darussalam in 1997 to that in 1999?
Make the answer very short. 1.04. What is the ratio of the Vaccinated children(%) in Cabo Verde in 1997 to that in 1999?
Keep it short and to the point. 0.98. What is the ratio of the Vaccinated children(%) of South Africa in 1997 to that in 1999?
Your answer should be very brief. 1.09. What is the ratio of the Vaccinated children(%) of OECD members in 1997 to that in 2000?
Your response must be concise. 0.97. What is the ratio of the Vaccinated children(%) of Cabo Verde in 1997 to that in 2000?
Give a very brief answer. 0.97. What is the ratio of the Vaccinated children(%) in South Africa in 1997 to that in 2000?
Provide a short and direct response. 1.14. What is the ratio of the Vaccinated children(%) of OECD members in 1997 to that in 2001?
Offer a very short reply. 0.97. What is the ratio of the Vaccinated children(%) of Cabo Verde in 1997 to that in 2001?
Your answer should be very brief. 0.94. What is the ratio of the Vaccinated children(%) of South Africa in 1997 to that in 2001?
Your response must be concise. 1.19. What is the ratio of the Vaccinated children(%) in Brunei Darussalam in 1998 to that in 1999?
Ensure brevity in your answer.  1.05. What is the ratio of the Vaccinated children(%) of South Africa in 1998 to that in 1999?
Offer a terse response. 1.05. What is the ratio of the Vaccinated children(%) of OECD members in 1998 to that in 2000?
Your response must be concise. 0.98. What is the ratio of the Vaccinated children(%) in Cabo Verde in 1998 to that in 2000?
Ensure brevity in your answer.  0.98. What is the ratio of the Vaccinated children(%) in South Africa in 1998 to that in 2000?
Your answer should be compact. 1.1. What is the ratio of the Vaccinated children(%) in OECD members in 1998 to that in 2001?
Your response must be concise. 0.98. What is the ratio of the Vaccinated children(%) of Brunei Darussalam in 1998 to that in 2001?
Provide a succinct answer. 1. What is the ratio of the Vaccinated children(%) in Cabo Verde in 1998 to that in 2001?
Your answer should be compact. 0.95. What is the ratio of the Vaccinated children(%) in South Africa in 1998 to that in 2001?
Offer a very short reply. 1.14. What is the ratio of the Vaccinated children(%) in Brunei Darussalam in 1999 to that in 2000?
Offer a very short reply. 0.95. What is the ratio of the Vaccinated children(%) in Cabo Verde in 1999 to that in 2000?
Give a very brief answer. 0.99. What is the ratio of the Vaccinated children(%) of South Africa in 1999 to that in 2000?
Your response must be concise. 1.04. What is the ratio of the Vaccinated children(%) of OECD members in 1999 to that in 2001?
Your answer should be very brief. 0.98. What is the ratio of the Vaccinated children(%) of Brunei Darussalam in 1999 to that in 2001?
Make the answer very short. 0.95. What is the ratio of the Vaccinated children(%) in Cabo Verde in 1999 to that in 2001?
Keep it short and to the point. 0.97. What is the ratio of the Vaccinated children(%) of South Africa in 1999 to that in 2001?
Offer a very short reply. 1.09. What is the ratio of the Vaccinated children(%) of Brunei Darussalam in 2000 to that in 2001?
Provide a succinct answer. 1. What is the ratio of the Vaccinated children(%) of Cabo Verde in 2000 to that in 2001?
Ensure brevity in your answer.  0.98. What is the ratio of the Vaccinated children(%) of South Africa in 2000 to that in 2001?
Make the answer very short. 1.04. What is the difference between the highest and the second highest Vaccinated children(%) of OECD members?
Your answer should be very brief. 0.55. What is the difference between the highest and the second highest Vaccinated children(%) of Cabo Verde?
Your answer should be very brief. 1. What is the difference between the highest and the lowest Vaccinated children(%) in OECD members?
Keep it short and to the point. 5.47. What is the difference between the highest and the lowest Vaccinated children(%) in Brunei Darussalam?
Offer a terse response. 5. What is the difference between the highest and the lowest Vaccinated children(%) of Cabo Verde?
Make the answer very short. 5. What is the difference between the highest and the lowest Vaccinated children(%) in South Africa?
Your answer should be compact. 13. 